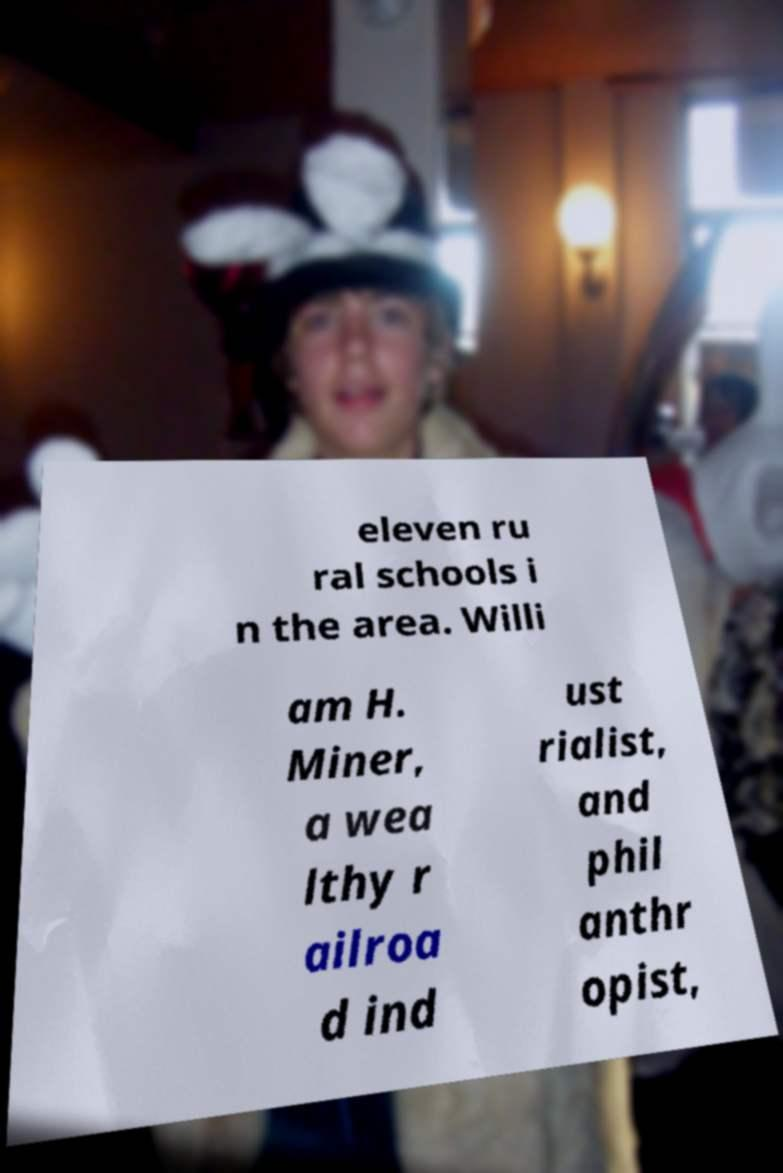I need the written content from this picture converted into text. Can you do that? eleven ru ral schools i n the area. Willi am H. Miner, a wea lthy r ailroa d ind ust rialist, and phil anthr opist, 